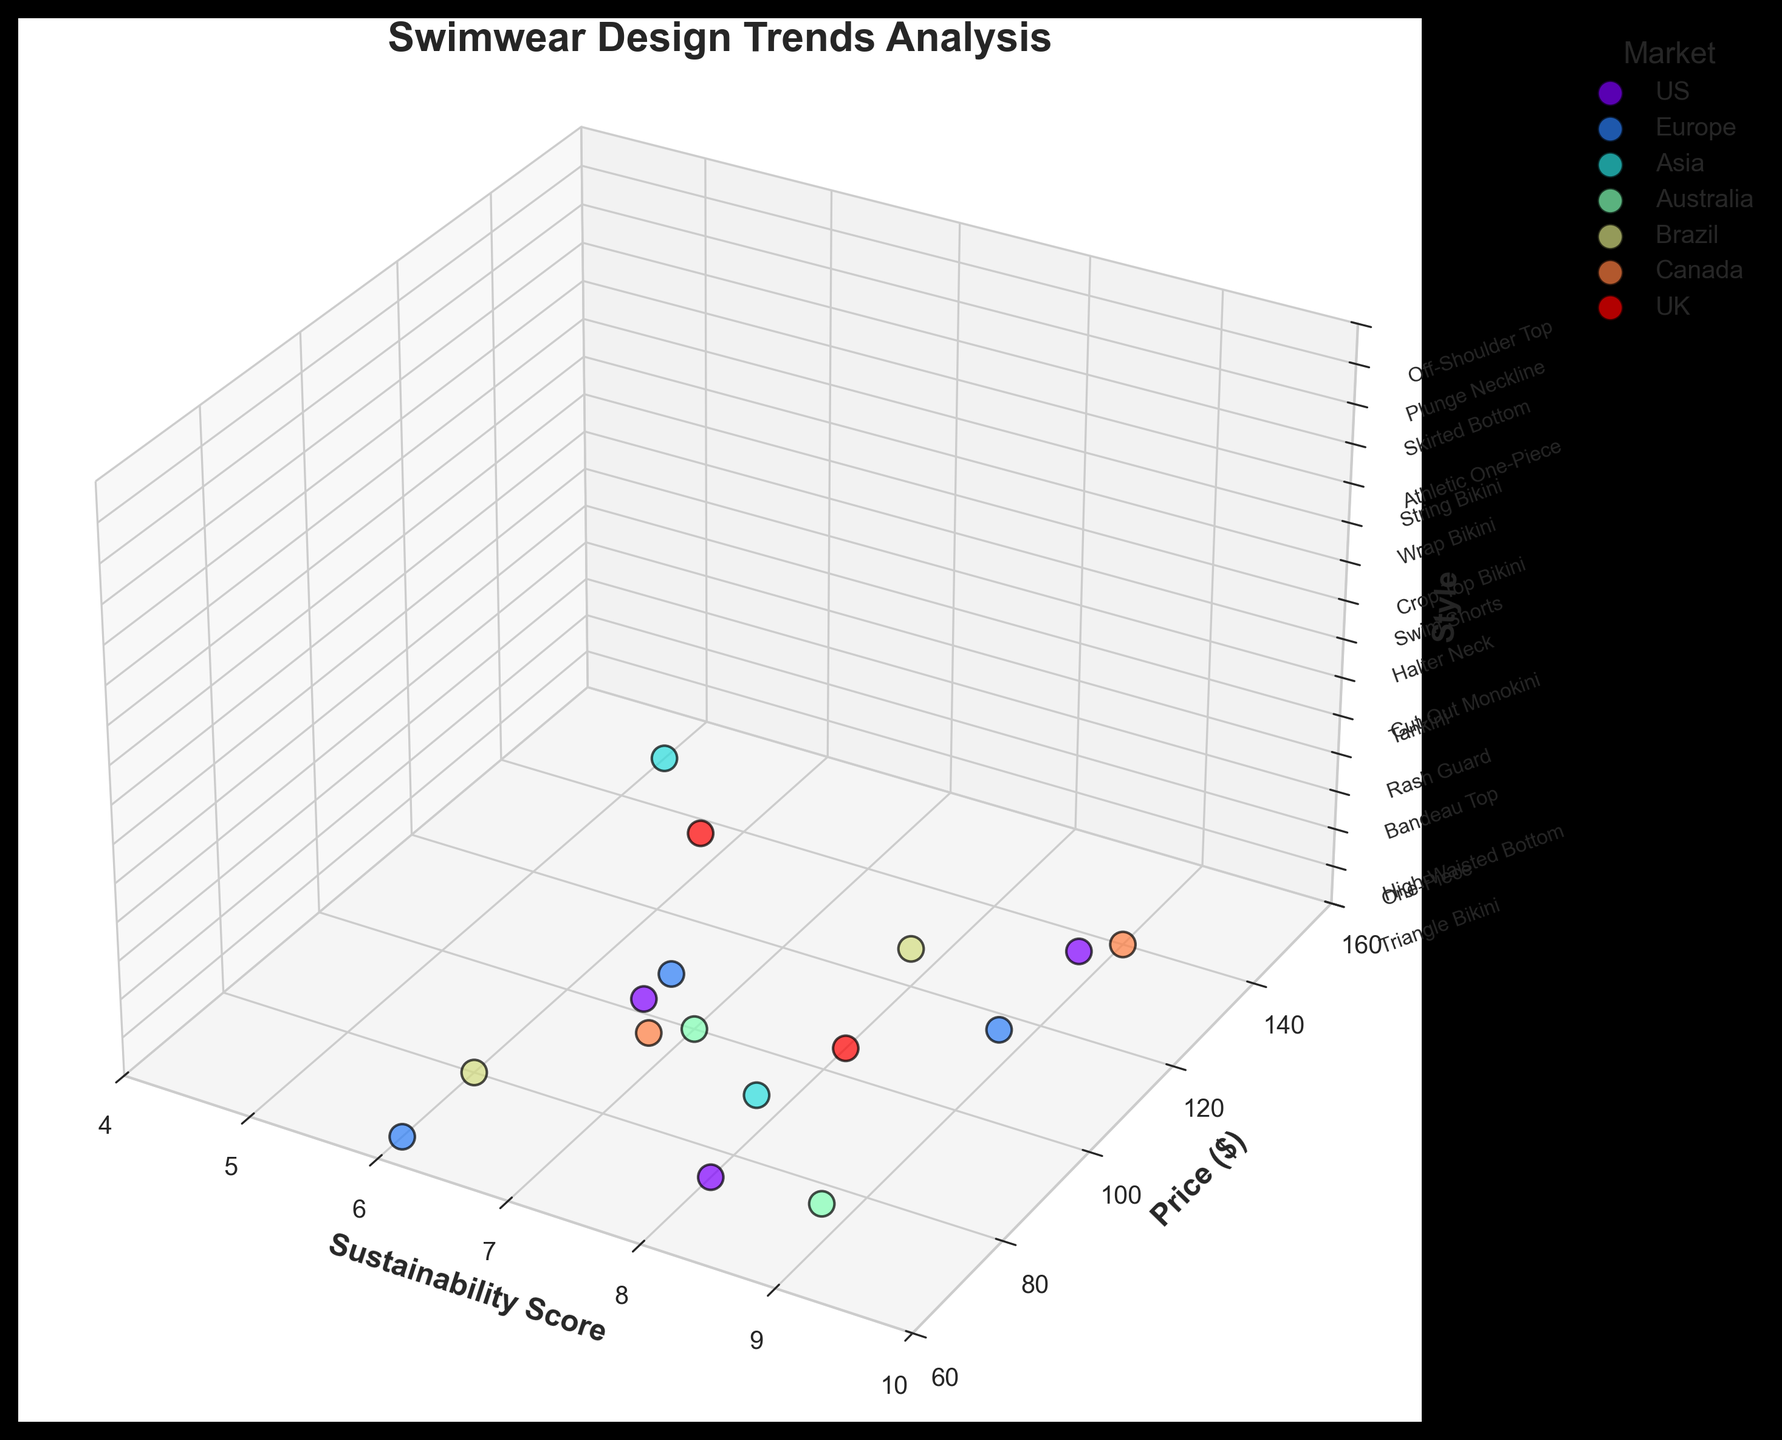What is the title of the plot? The title is generally displayed at the top of the figure.
Answer: Swimwear Design Trends Analysis Which market has the highest-priced swimwear? By looking at the y-axis (Price) and identifying the highest point, we see that 'Athletic One-Piece' in Canada is the highest at $140.
Answer: Canada Which swimwear style from the US has the highest sustainability score? By locating the US market points and comparing their sustainability scores along the x-axis, 'One-Piece' has the highest score of 9.
Answer: One-Piece Which two styles have an equal sustainability score and belong to different markets? By checking for pairs of points that have the same x-axis value, 'One-Piece' from the US and 'Rash Guard' from Europe both have a score of 9.
Answer: One-Piece (US) and Rash Guard (Europe) Which market shows the most variety in swimwear styles? By counting the number of unique styles appearing in each market (colors), the US and Europe have the most at 3 each.
Answer: US and Europe How does the sustainability score of 'High-Waisted Bottom' in the US compare to 'Wrap Bikini' in Brazil? Identify the sustainability scores for both styles, 'High-Waisted Bottom' has a score of 8, and 'Wrap Bikini' also has a score of 8.
Answer: They are equal Which swimwear style in the Asia market has the highest price? Look at the points associated with Asia and find the highest y-axis (price) value, 'Cut-Out Monokini' at $150.
Answer: Cut-Out Monokini Which market offers the most sustainable swimwear on average? Calculate the average sustainability scores for all markets and compare. E.g., US: (7+9+8)/3=8, Europe: (6+9+7)/3=7.33, Asia: (5+8)/2=6.5, Australia: (9+7)/2=8, Brazil: (8+6)/2=7, Canada: (9+7)/2=8, UK: (6+8)/2=7
Answer: Tie among US, Australia, and Canada Which swimwear style in the UK has a higher price, 'Plunge Neckline' or 'Off-Shoulder Top'? Compare the y-axis values (prices) for the two UK styles, 'Plunge Neckline' is $130, whereas 'Off-Shoulder Top' is $105.
Answer: Plunge Neckline 